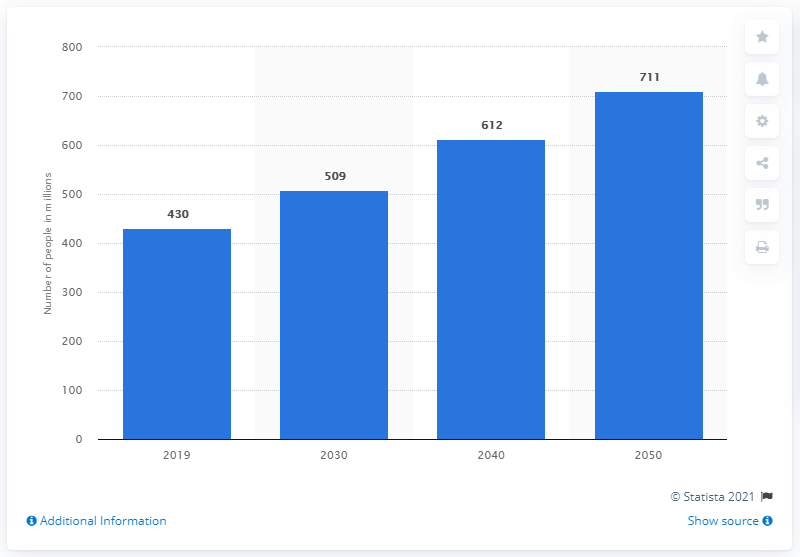Outline some significant characteristics in this image. In 2019, an estimated 430 people suffered from hearing loss. By the year 2050, it is projected that the number of people with hearing loss will reach 711. 